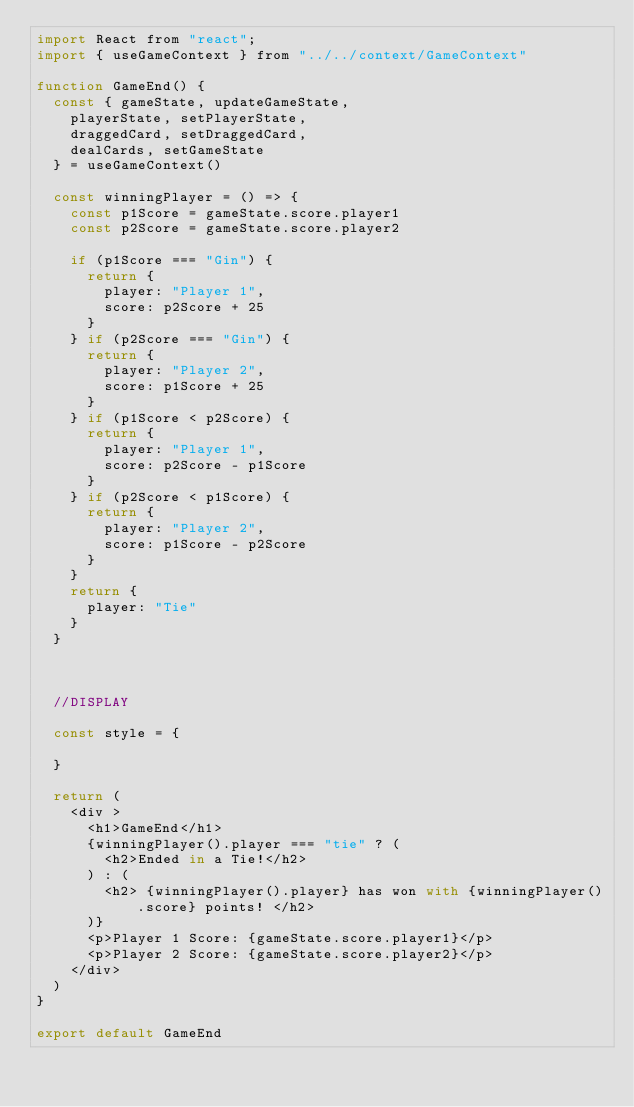<code> <loc_0><loc_0><loc_500><loc_500><_JavaScript_>import React from "react";
import { useGameContext } from "../../context/GameContext"

function GameEnd() {
  const { gameState, updateGameState,
    playerState, setPlayerState,
    draggedCard, setDraggedCard,
    dealCards, setGameState
  } = useGameContext()

  const winningPlayer = () => {
    const p1Score = gameState.score.player1
    const p2Score = gameState.score.player2

    if (p1Score === "Gin") {
      return {
        player: "Player 1",
        score: p2Score + 25
      }
    } if (p2Score === "Gin") {
      return {
        player: "Player 2",
        score: p1Score + 25
      }
    } if (p1Score < p2Score) {
      return {
        player: "Player 1",
        score: p2Score - p1Score
      }
    } if (p2Score < p1Score) {
      return {
        player: "Player 2",
        score: p1Score - p2Score
      }
    }
    return {
      player: "Tie"
    }
  }



  //DISPLAY

  const style = {

  }

  return (
    <div >
      <h1>GameEnd</h1>
      {winningPlayer().player === "tie" ? (
        <h2>Ended in a Tie!</h2>
      ) : (
        <h2> {winningPlayer().player} has won with {winningPlayer().score} points! </h2>
      )}
      <p>Player 1 Score: {gameState.score.player1}</p>
      <p>Player 2 Score: {gameState.score.player2}</p>
    </div>
  )
}

export default GameEnd
</code> 